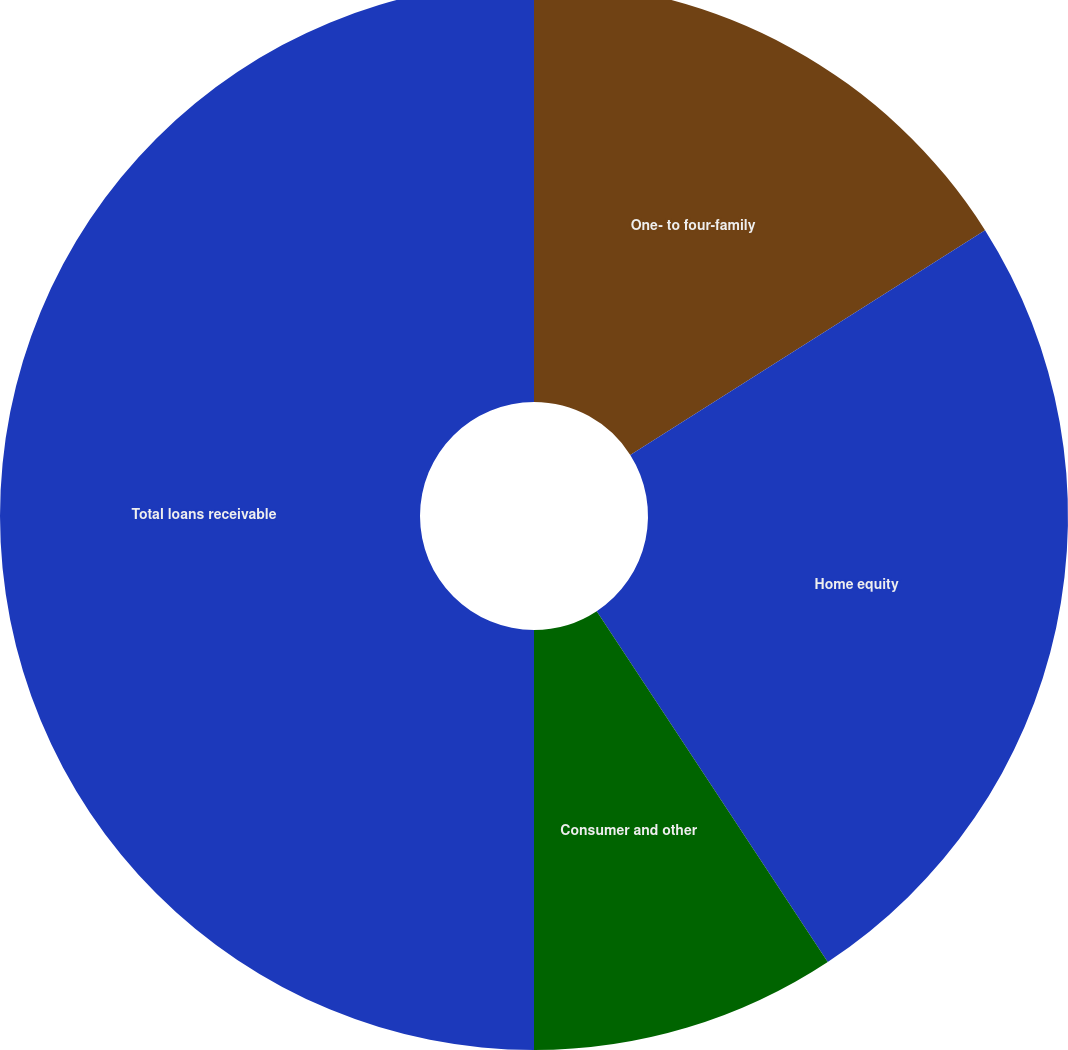Convert chart. <chart><loc_0><loc_0><loc_500><loc_500><pie_chart><fcel>One- to four-family<fcel>Home equity<fcel>Consumer and other<fcel>Total loans receivable<nl><fcel>16.01%<fcel>24.72%<fcel>9.27%<fcel>50.0%<nl></chart> 